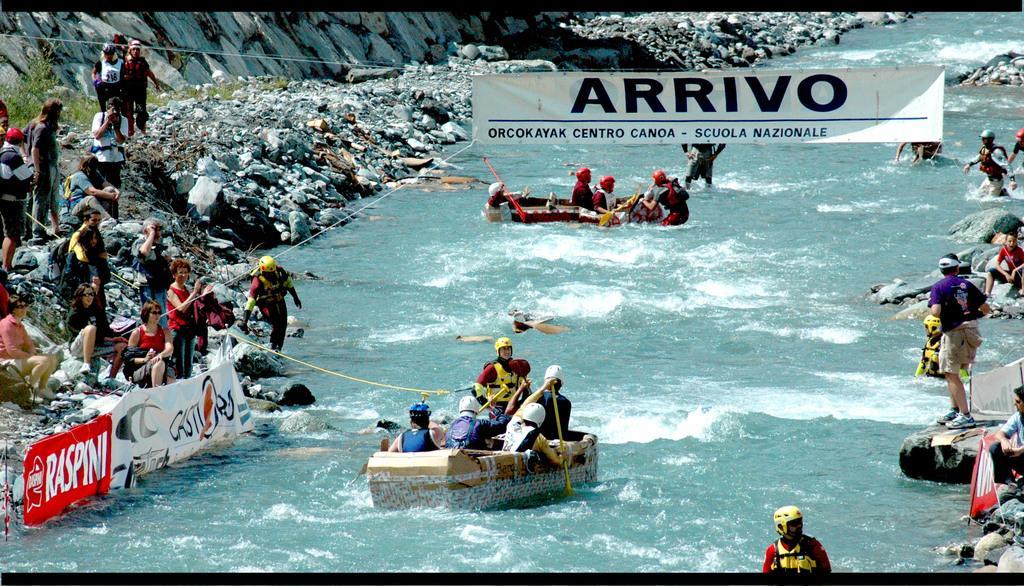How would you summarize this image in a sentence or two? In the image there are few people kayaking on boats in middle of the canal, on either side of it there are few peoples standing on the rocky land and above there is a banner. 